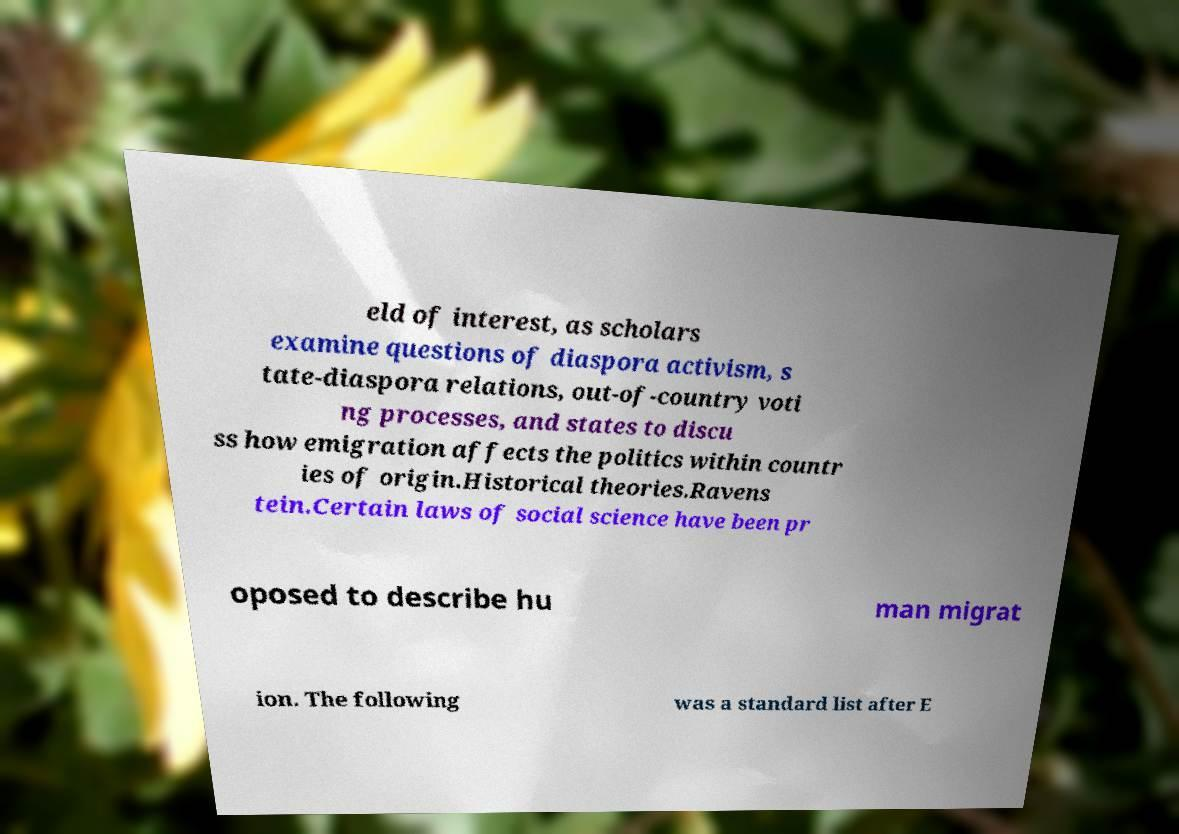For documentation purposes, I need the text within this image transcribed. Could you provide that? eld of interest, as scholars examine questions of diaspora activism, s tate-diaspora relations, out-of-country voti ng processes, and states to discu ss how emigration affects the politics within countr ies of origin.Historical theories.Ravens tein.Certain laws of social science have been pr oposed to describe hu man migrat ion. The following was a standard list after E 